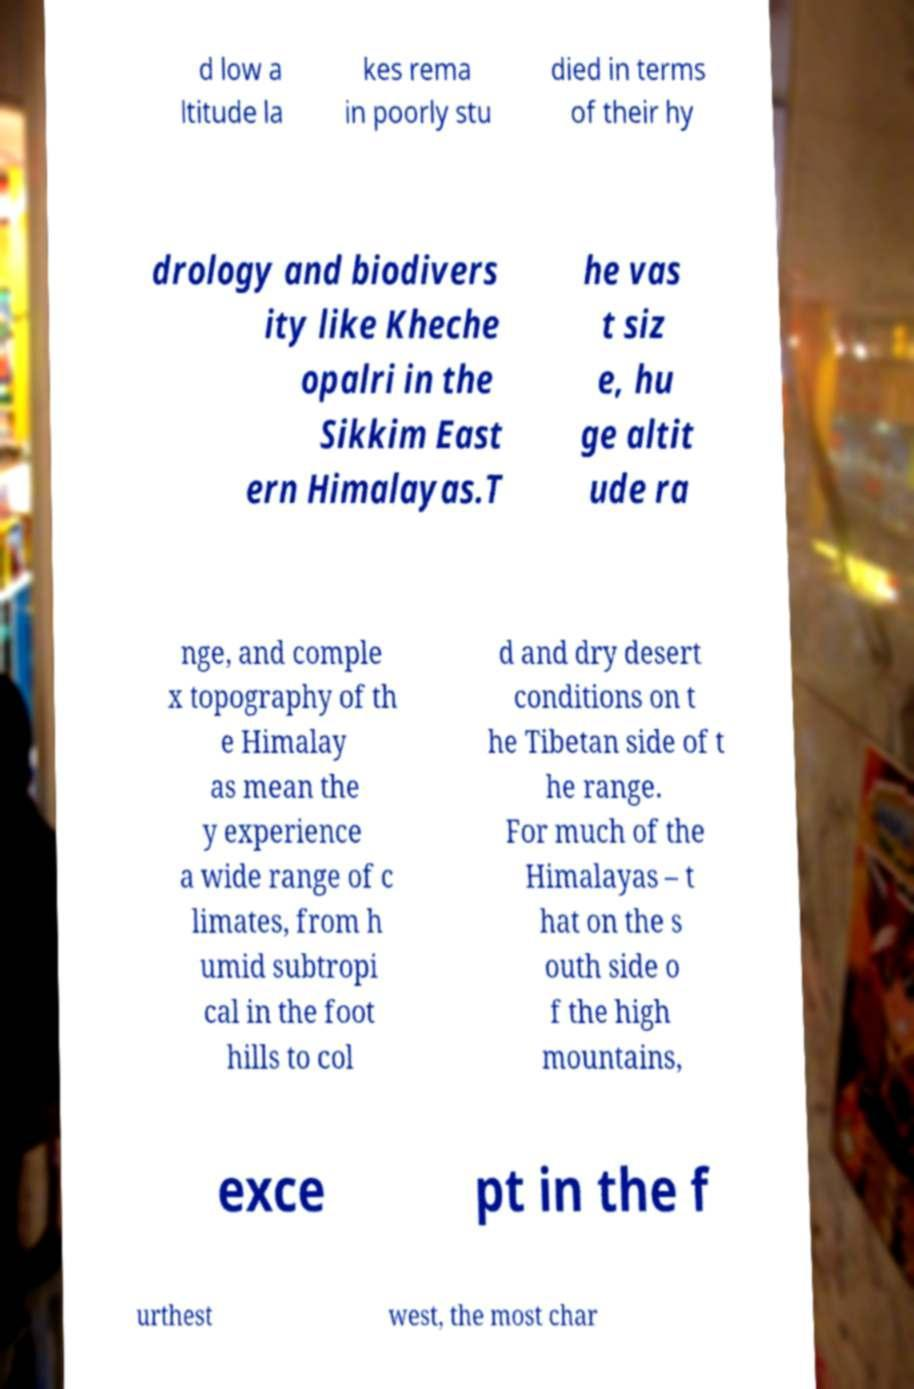Can you read and provide the text displayed in the image?This photo seems to have some interesting text. Can you extract and type it out for me? d low a ltitude la kes rema in poorly stu died in terms of their hy drology and biodivers ity like Kheche opalri in the Sikkim East ern Himalayas.T he vas t siz e, hu ge altit ude ra nge, and comple x topography of th e Himalay as mean the y experience a wide range of c limates, from h umid subtropi cal in the foot hills to col d and dry desert conditions on t he Tibetan side of t he range. For much of the Himalayas – t hat on the s outh side o f the high mountains, exce pt in the f urthest west, the most char 